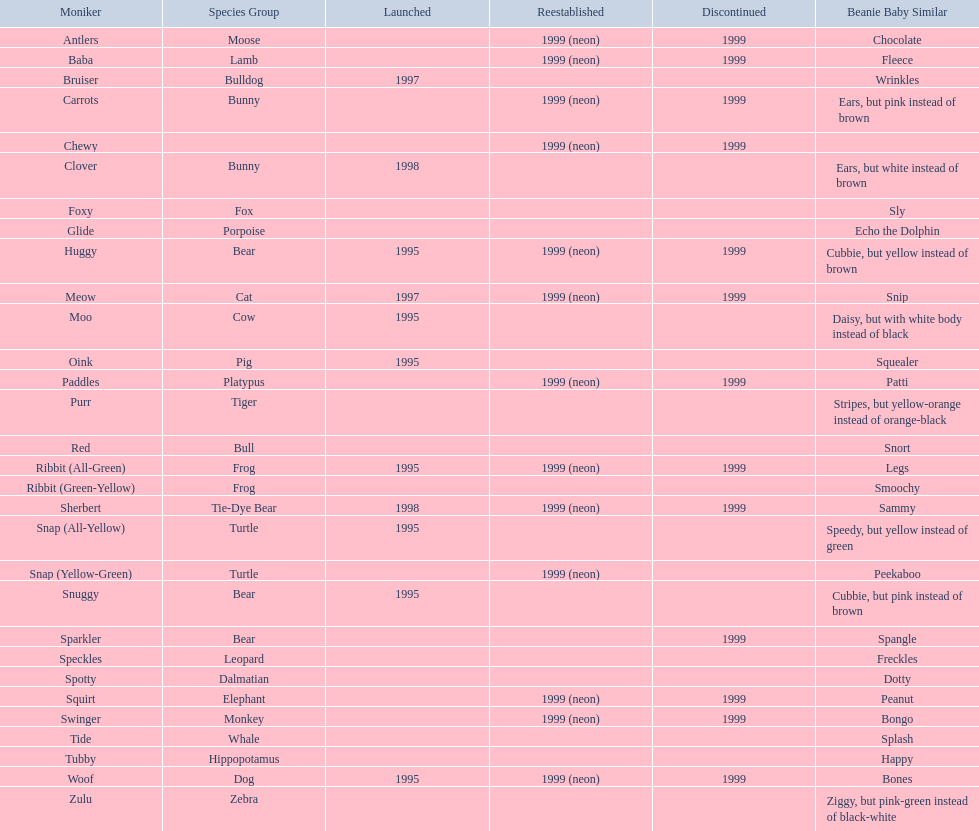What are the names listed? Antlers, Baba, Bruiser, Carrots, Chewy, Clover, Foxy, Glide, Huggy, Meow, Moo, Oink, Paddles, Purr, Red, Ribbit (All-Green), Ribbit (Green-Yellow), Sherbert, Snap (All-Yellow), Snap (Yellow-Green), Snuggy, Sparkler, Speckles, Spotty, Squirt, Swinger, Tide, Tubby, Woof, Zulu. Of these, which is the only pet without an animal type listed? Chewy. 